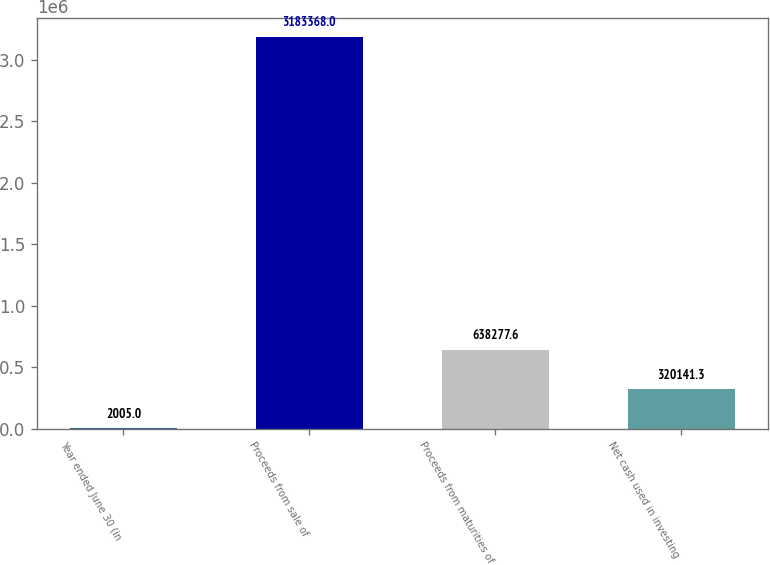Convert chart to OTSL. <chart><loc_0><loc_0><loc_500><loc_500><bar_chart><fcel>Year ended June 30 (in<fcel>Proceeds from sale of<fcel>Proceeds from maturities of<fcel>Net cash used in investing<nl><fcel>2005<fcel>3.18337e+06<fcel>638278<fcel>320141<nl></chart> 